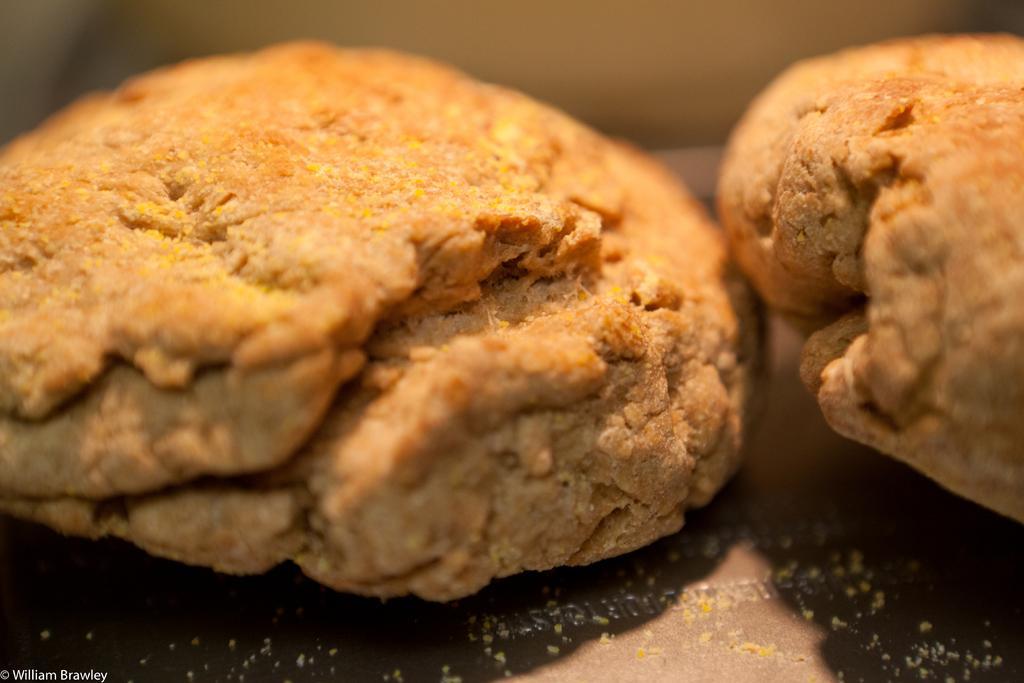Could you give a brief overview of what you see in this image? In this image we can see cookies on a plate and in the background the image is blur. 